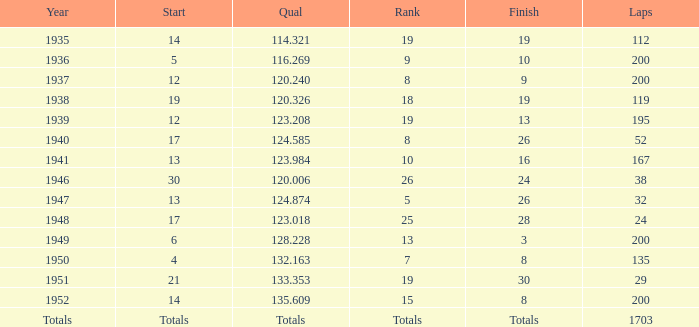In 1939, what was the finish? 13.0. 